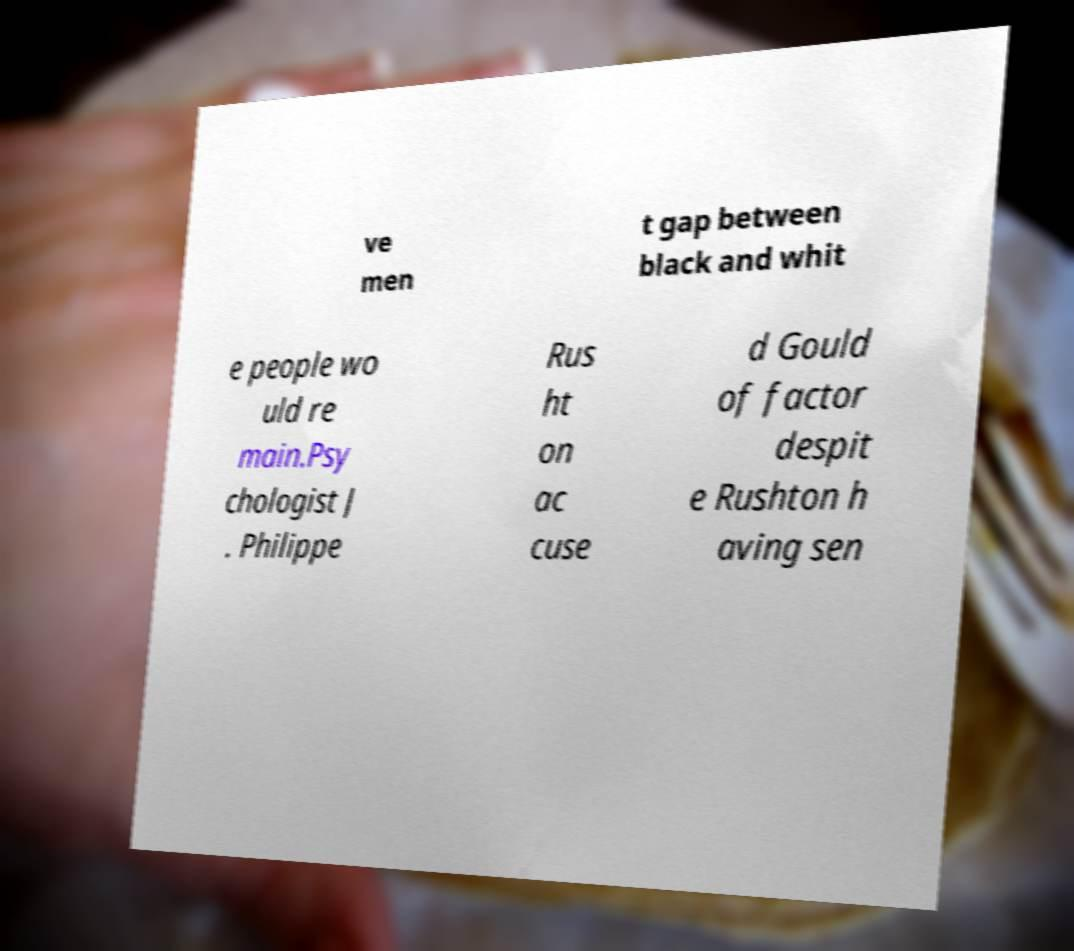I need the written content from this picture converted into text. Can you do that? ve men t gap between black and whit e people wo uld re main.Psy chologist J . Philippe Rus ht on ac cuse d Gould of factor despit e Rushton h aving sen 